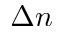Convert formula to latex. <formula><loc_0><loc_0><loc_500><loc_500>\Delta { n }</formula> 